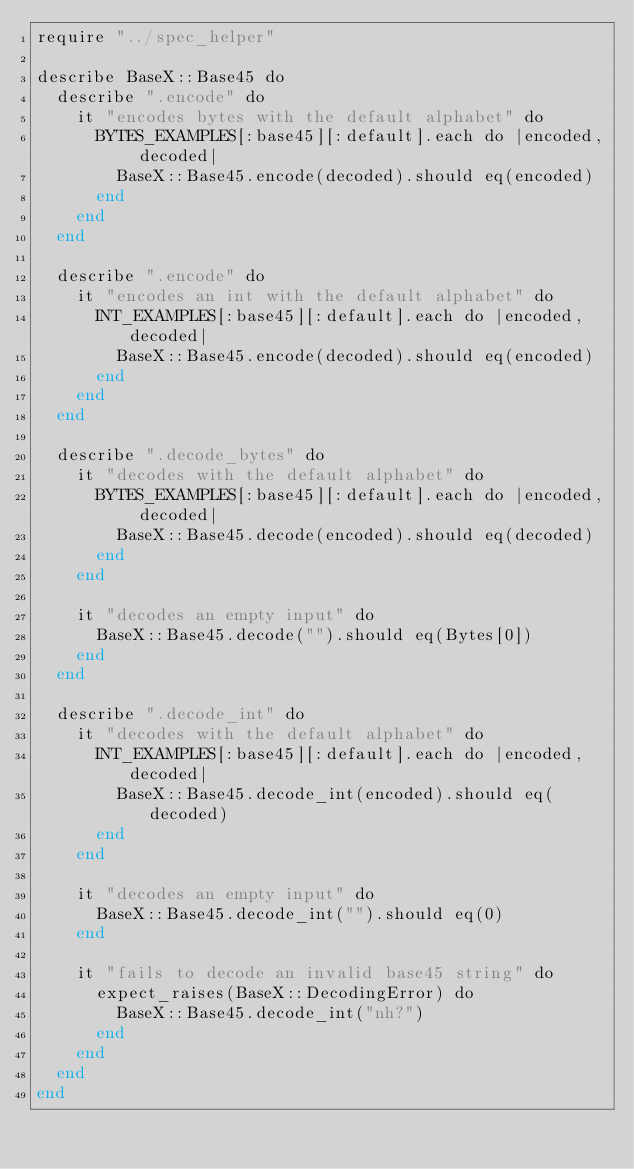Convert code to text. <code><loc_0><loc_0><loc_500><loc_500><_Crystal_>require "../spec_helper"

describe BaseX::Base45 do
  describe ".encode" do
    it "encodes bytes with the default alphabet" do
      BYTES_EXAMPLES[:base45][:default].each do |encoded, decoded|
        BaseX::Base45.encode(decoded).should eq(encoded)
      end
    end
  end

  describe ".encode" do
    it "encodes an int with the default alphabet" do
      INT_EXAMPLES[:base45][:default].each do |encoded, decoded|
        BaseX::Base45.encode(decoded).should eq(encoded)
      end
    end
  end

  describe ".decode_bytes" do
    it "decodes with the default alphabet" do
      BYTES_EXAMPLES[:base45][:default].each do |encoded, decoded|
        BaseX::Base45.decode(encoded).should eq(decoded)
      end
    end

    it "decodes an empty input" do
      BaseX::Base45.decode("").should eq(Bytes[0])
    end
  end

  describe ".decode_int" do
    it "decodes with the default alphabet" do
      INT_EXAMPLES[:base45][:default].each do |encoded, decoded|
        BaseX::Base45.decode_int(encoded).should eq(decoded)
      end
    end

    it "decodes an empty input" do
      BaseX::Base45.decode_int("").should eq(0)
    end

    it "fails to decode an invalid base45 string" do
      expect_raises(BaseX::DecodingError) do
        BaseX::Base45.decode_int("nh?")
      end
    end
  end
end
</code> 